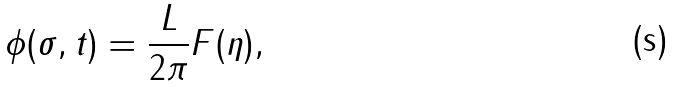Convert formula to latex. <formula><loc_0><loc_0><loc_500><loc_500>\phi ( \sigma , t ) = \frac { L } { 2 \pi } F ( \eta ) ,</formula> 